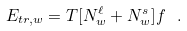Convert formula to latex. <formula><loc_0><loc_0><loc_500><loc_500>E _ { t r , w } = T [ N _ { w } ^ { \ell } + N _ { w } ^ { s } ] f \ .</formula> 